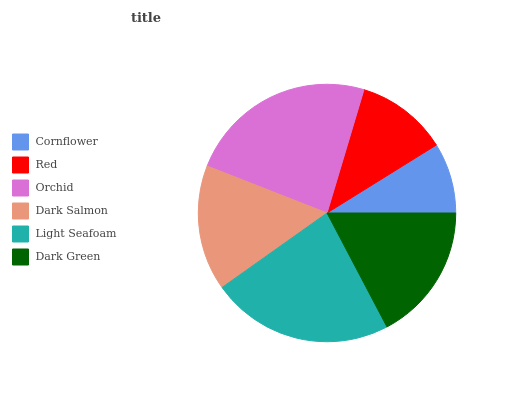Is Cornflower the minimum?
Answer yes or no. Yes. Is Orchid the maximum?
Answer yes or no. Yes. Is Red the minimum?
Answer yes or no. No. Is Red the maximum?
Answer yes or no. No. Is Red greater than Cornflower?
Answer yes or no. Yes. Is Cornflower less than Red?
Answer yes or no. Yes. Is Cornflower greater than Red?
Answer yes or no. No. Is Red less than Cornflower?
Answer yes or no. No. Is Dark Green the high median?
Answer yes or no. Yes. Is Dark Salmon the low median?
Answer yes or no. Yes. Is Light Seafoam the high median?
Answer yes or no. No. Is Dark Green the low median?
Answer yes or no. No. 